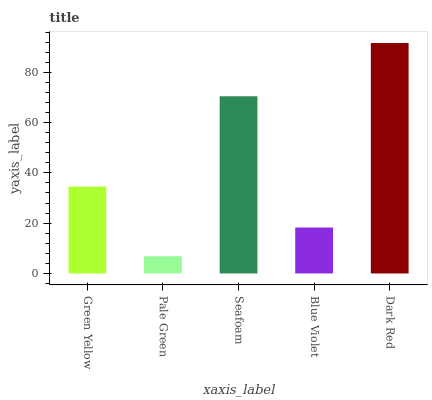Is Pale Green the minimum?
Answer yes or no. Yes. Is Dark Red the maximum?
Answer yes or no. Yes. Is Seafoam the minimum?
Answer yes or no. No. Is Seafoam the maximum?
Answer yes or no. No. Is Seafoam greater than Pale Green?
Answer yes or no. Yes. Is Pale Green less than Seafoam?
Answer yes or no. Yes. Is Pale Green greater than Seafoam?
Answer yes or no. No. Is Seafoam less than Pale Green?
Answer yes or no. No. Is Green Yellow the high median?
Answer yes or no. Yes. Is Green Yellow the low median?
Answer yes or no. Yes. Is Dark Red the high median?
Answer yes or no. No. Is Dark Red the low median?
Answer yes or no. No. 